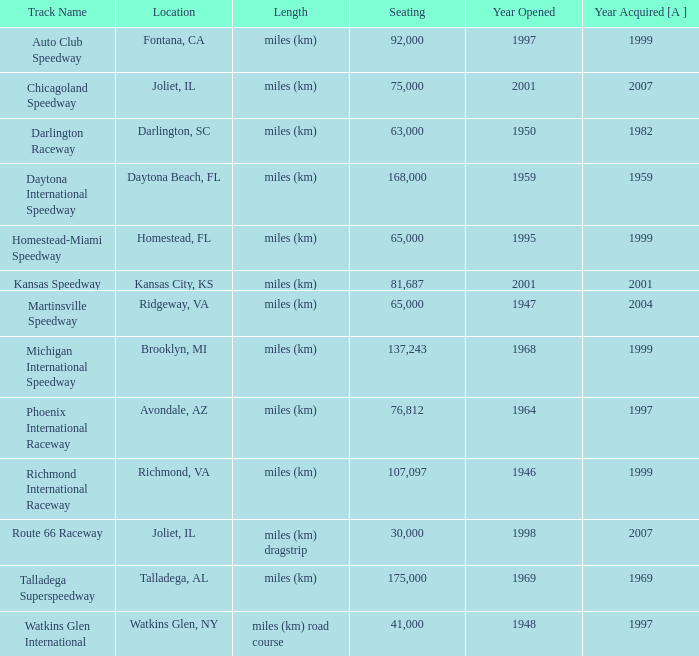What is the year opened for Chicagoland Speedway with a seating smaller than 75,000? None. 